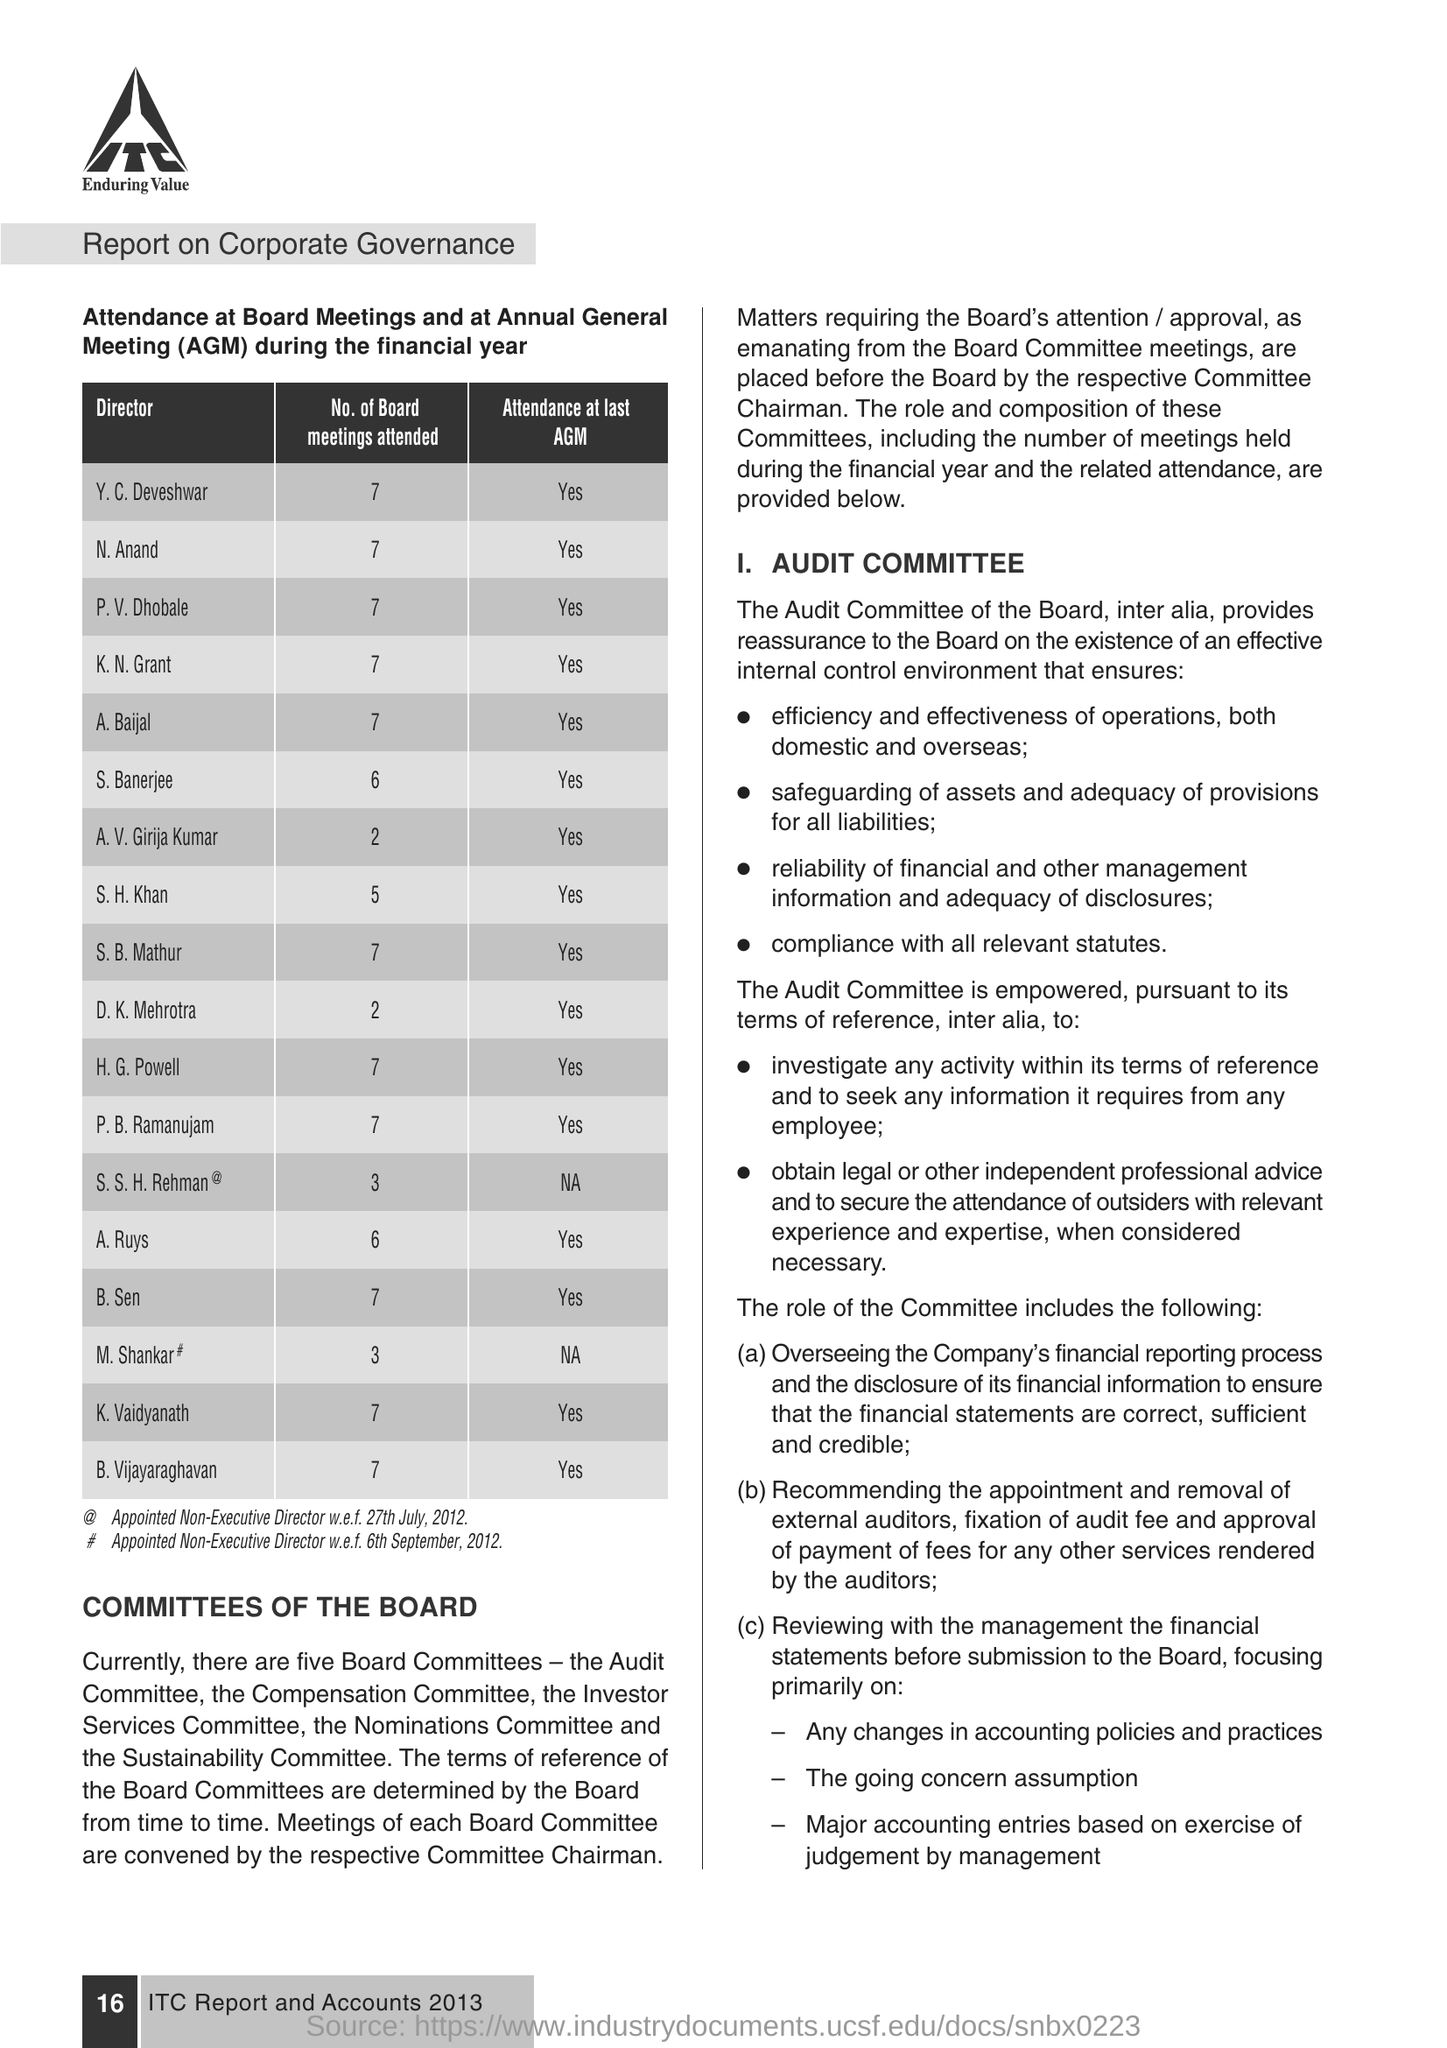Highlight a few significant elements in this photo. The K.N.Grant attended 7 meetings. The full form of AGM is Annual General Meeting. 